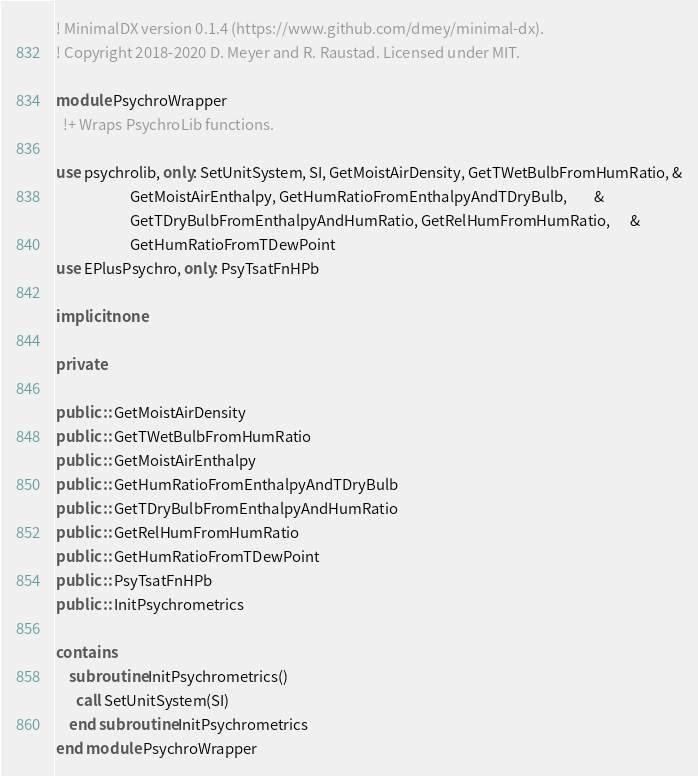<code> <loc_0><loc_0><loc_500><loc_500><_FORTRAN_>! MinimalDX version 0.1.4 (https://www.github.com/dmey/minimal-dx).
! Copyright 2018-2020 D. Meyer and R. Raustad. Licensed under MIT.

module PsychroWrapper
  !+ Wraps PsychroLib functions.

use psychrolib, only: SetUnitSystem, SI, GetMoistAirDensity, GetTWetBulbFromHumRatio, &
                      GetMoistAirEnthalpy, GetHumRatioFromEnthalpyAndTDryBulb,        &
                      GetTDryBulbFromEnthalpyAndHumRatio, GetRelHumFromHumRatio,      &
                      GetHumRatioFromTDewPoint
use EPlusPsychro, only: PsyTsatFnHPb

implicit none

private

public :: GetMoistAirDensity
public :: GetTWetBulbFromHumRatio
public :: GetMoistAirEnthalpy
public :: GetHumRatioFromEnthalpyAndTDryBulb
public :: GetTDryBulbFromEnthalpyAndHumRatio
public :: GetRelHumFromHumRatio
public :: GetHumRatioFromTDewPoint
public :: PsyTsatFnHPb
public :: InitPsychrometrics

contains
    subroutine InitPsychrometrics()
      call SetUnitSystem(SI)
    end subroutine InitPsychrometrics
end module PsychroWrapper
</code> 